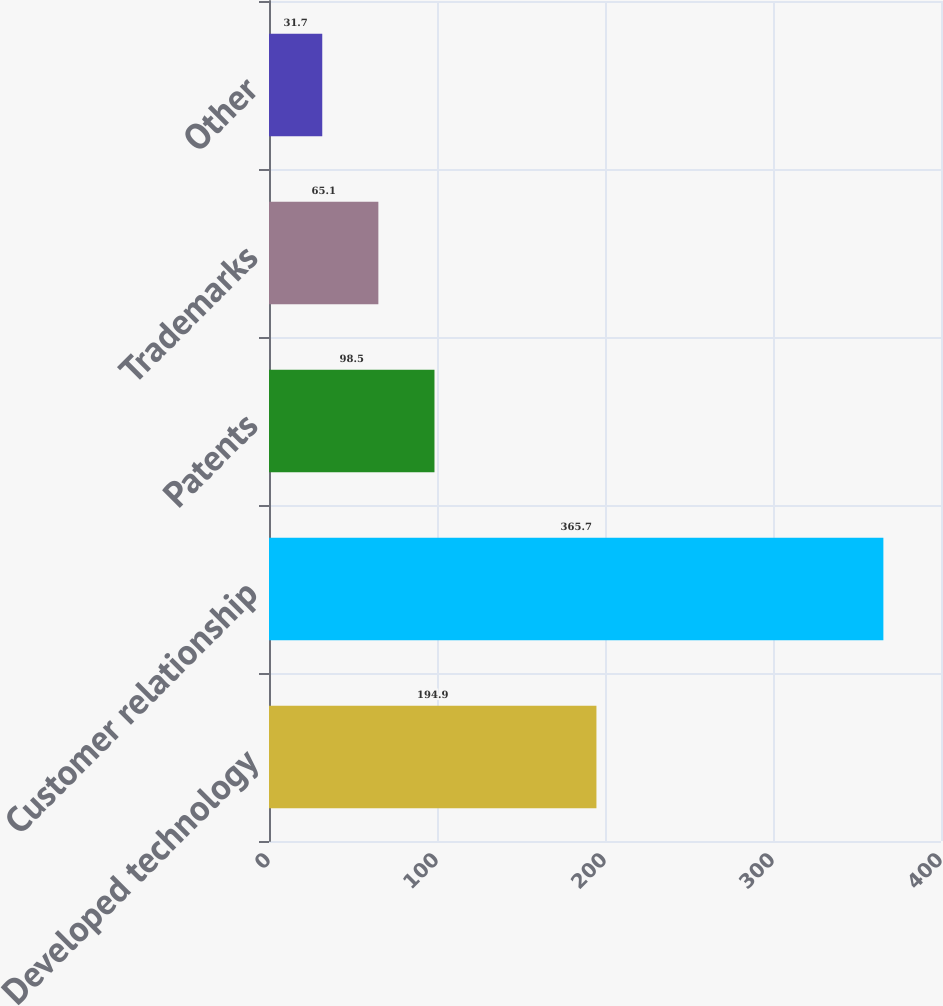Convert chart to OTSL. <chart><loc_0><loc_0><loc_500><loc_500><bar_chart><fcel>Developed technology<fcel>Customer relationship<fcel>Patents<fcel>Trademarks<fcel>Other<nl><fcel>194.9<fcel>365.7<fcel>98.5<fcel>65.1<fcel>31.7<nl></chart> 